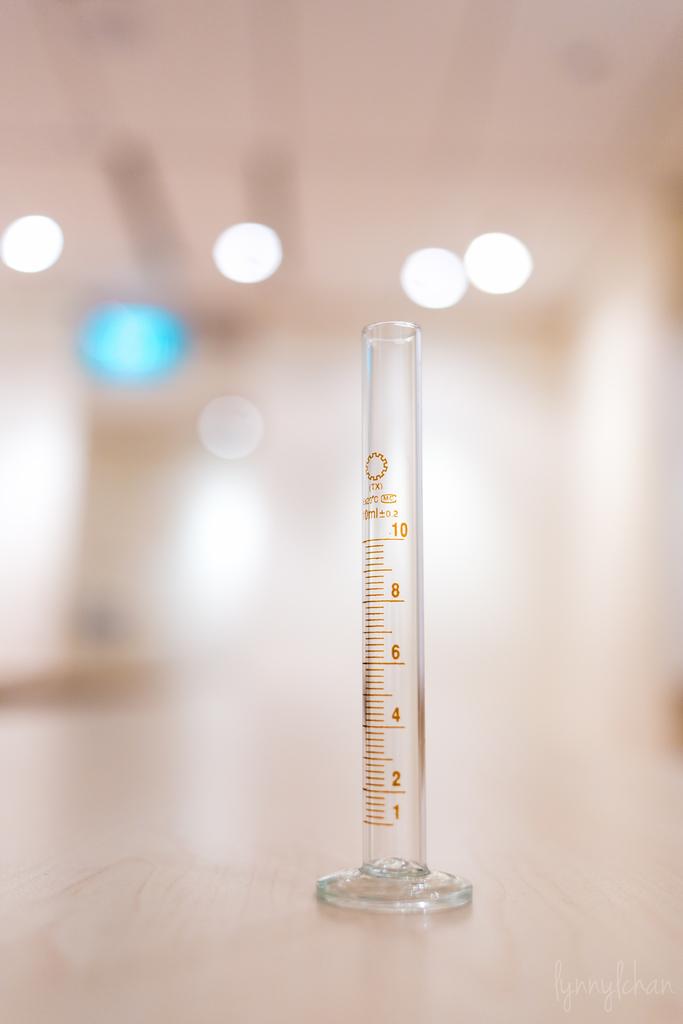What is the highest number measured with the instrument?
Make the answer very short. 10. What is the lowest number measured with the instrument?
Provide a short and direct response. 1. 